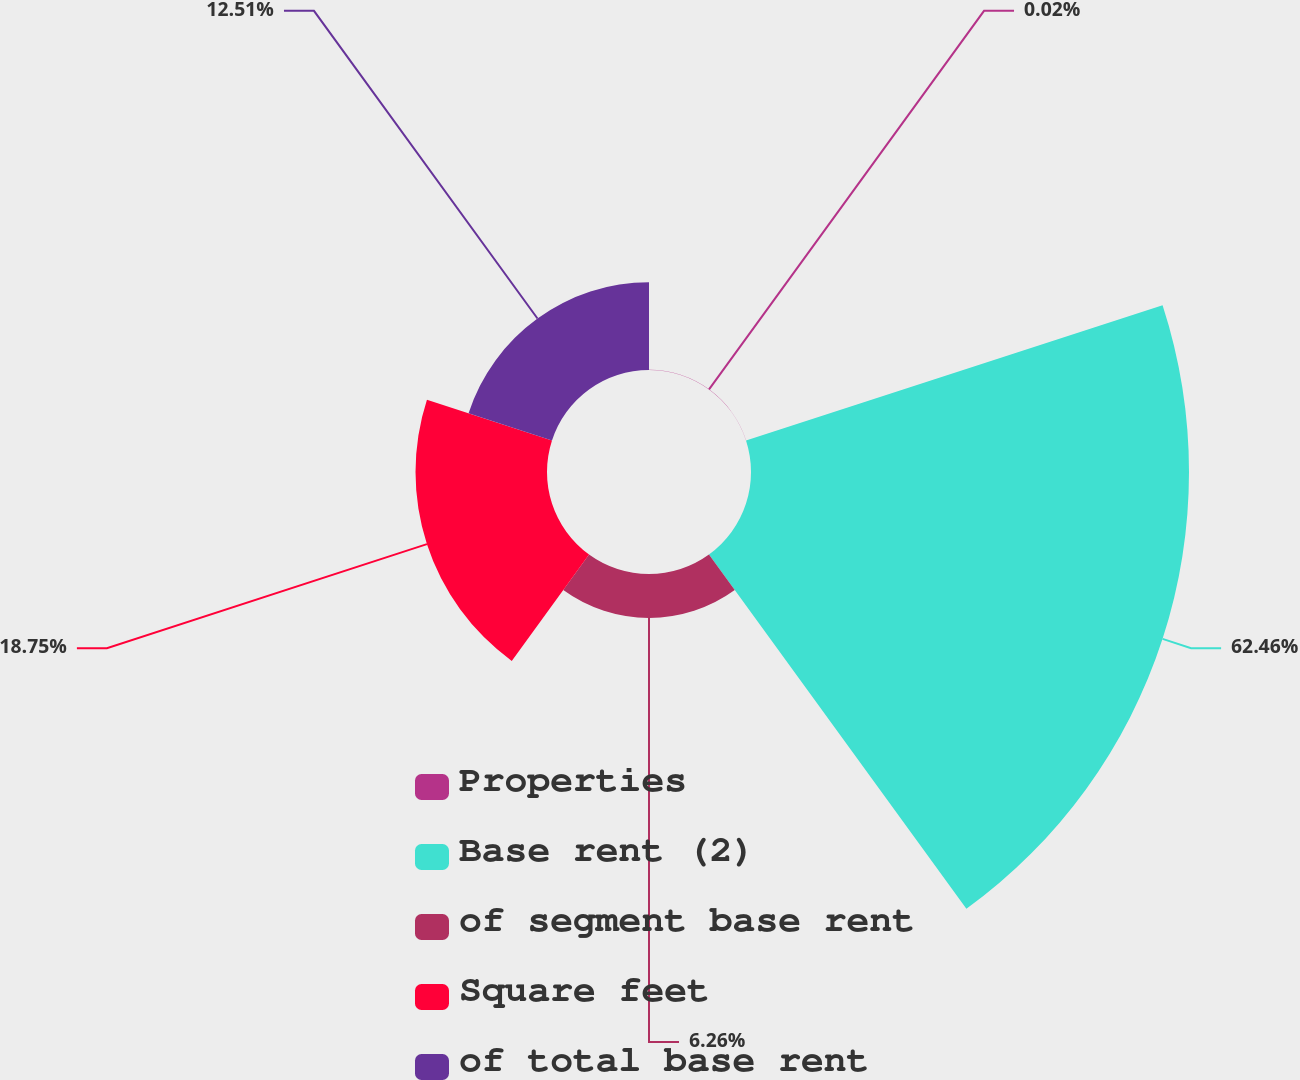Convert chart to OTSL. <chart><loc_0><loc_0><loc_500><loc_500><pie_chart><fcel>Properties<fcel>Base rent (2)<fcel>of segment base rent<fcel>Square feet<fcel>of total base rent<nl><fcel>0.02%<fcel>62.46%<fcel>6.26%<fcel>18.75%<fcel>12.51%<nl></chart> 